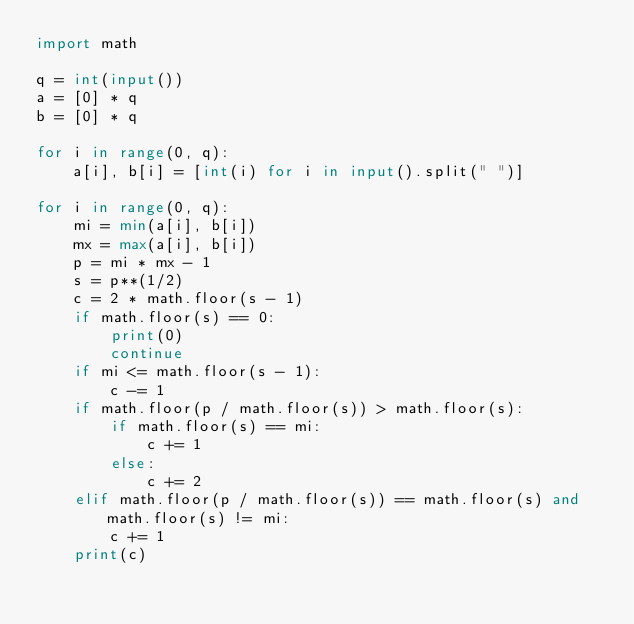<code> <loc_0><loc_0><loc_500><loc_500><_Python_>import math

q = int(input())
a = [0] * q
b = [0] * q

for i in range(0, q):
    a[i], b[i] = [int(i) for i in input().split(" ")]

for i in range(0, q):
    mi = min(a[i], b[i])
    mx = max(a[i], b[i])
    p = mi * mx - 1
    s = p**(1/2)
    c = 2 * math.floor(s - 1)
    if math.floor(s) == 0:
        print(0)
        continue
    if mi <= math.floor(s - 1):
        c -= 1
    if math.floor(p / math.floor(s)) > math.floor(s):
        if math.floor(s) == mi:
            c += 1
        else:
            c += 2
    elif math.floor(p / math.floor(s)) == math.floor(s) and math.floor(s) != mi:
        c += 1
    print(c)</code> 